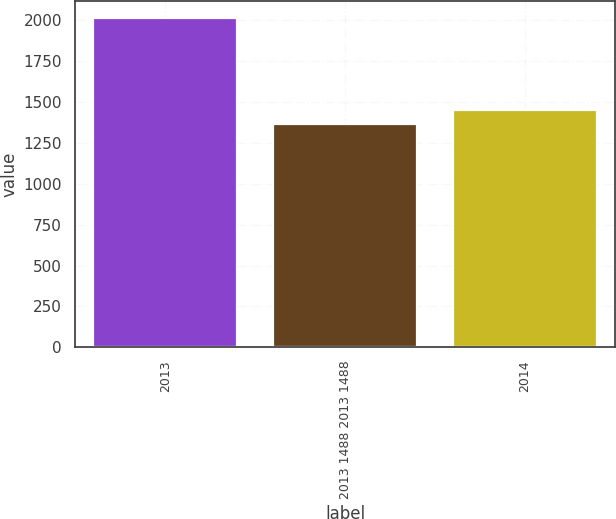<chart> <loc_0><loc_0><loc_500><loc_500><bar_chart><fcel>2013<fcel>2013 1488 2013 1488<fcel>2014<nl><fcel>2015<fcel>1365<fcel>1450<nl></chart> 